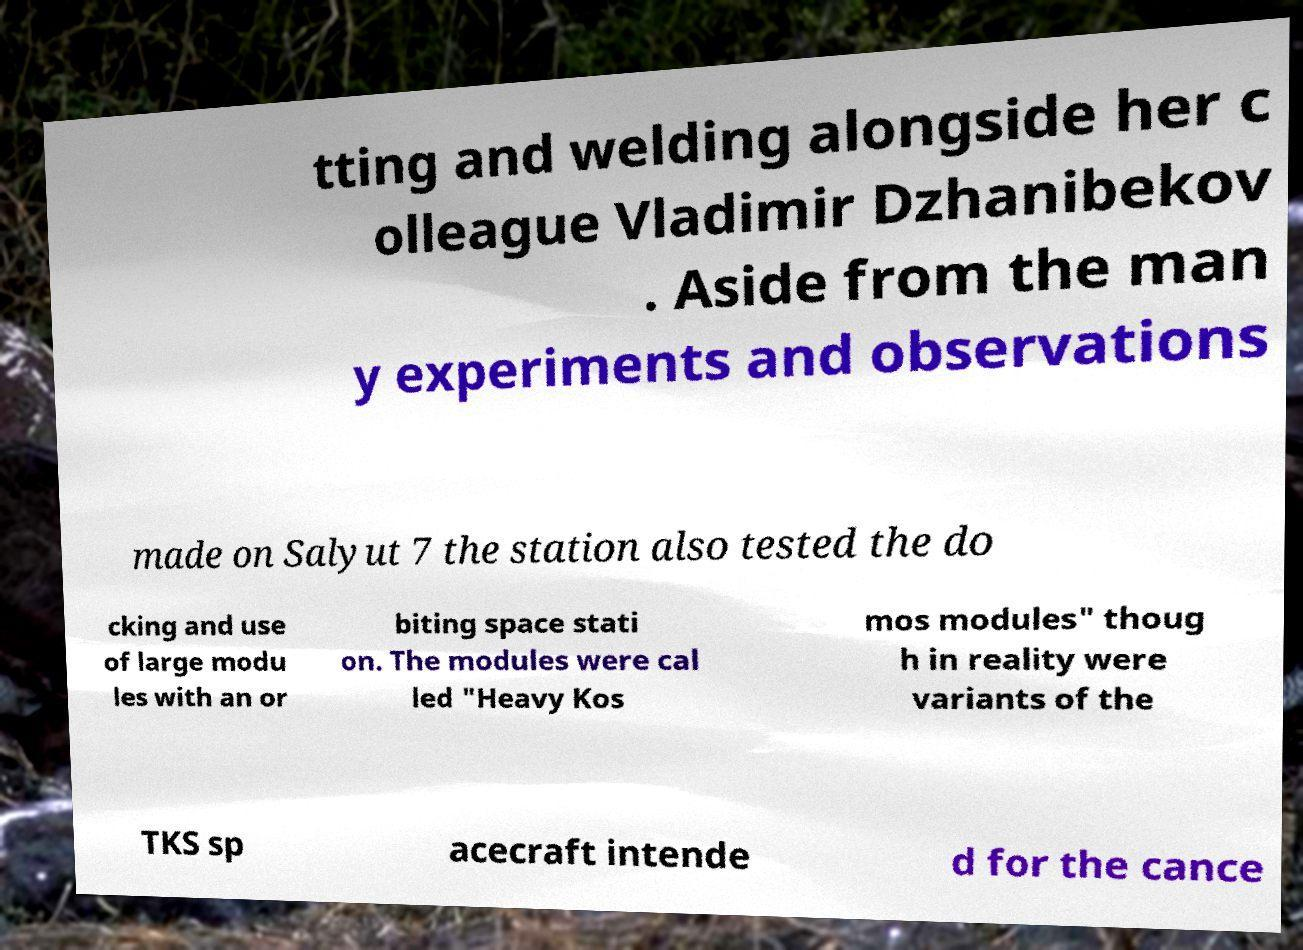What messages or text are displayed in this image? I need them in a readable, typed format. tting and welding alongside her c olleague Vladimir Dzhanibekov . Aside from the man y experiments and observations made on Salyut 7 the station also tested the do cking and use of large modu les with an or biting space stati on. The modules were cal led "Heavy Kos mos modules" thoug h in reality were variants of the TKS sp acecraft intende d for the cance 